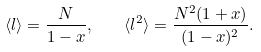<formula> <loc_0><loc_0><loc_500><loc_500>\langle l \rangle = \frac { N } { 1 - x } , \quad \langle l ^ { 2 } \rangle = \frac { N ^ { 2 } ( 1 + x ) } { ( 1 - x ) ^ { 2 } } .</formula> 